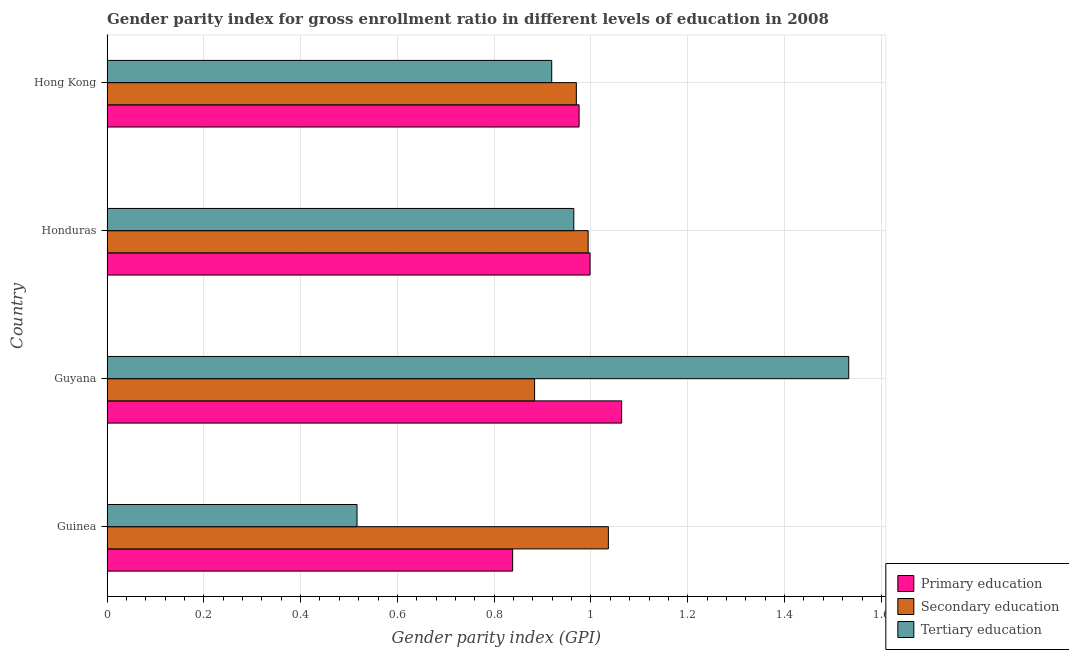How many different coloured bars are there?
Provide a succinct answer. 3. Are the number of bars on each tick of the Y-axis equal?
Provide a succinct answer. Yes. How many bars are there on the 4th tick from the top?
Provide a succinct answer. 3. What is the label of the 1st group of bars from the top?
Give a very brief answer. Hong Kong. In how many cases, is the number of bars for a given country not equal to the number of legend labels?
Give a very brief answer. 0. What is the gender parity index in secondary education in Honduras?
Offer a very short reply. 0.99. Across all countries, what is the maximum gender parity index in primary education?
Your answer should be very brief. 1.06. Across all countries, what is the minimum gender parity index in tertiary education?
Give a very brief answer. 0.52. In which country was the gender parity index in primary education maximum?
Offer a terse response. Guyana. In which country was the gender parity index in tertiary education minimum?
Ensure brevity in your answer.  Guinea. What is the total gender parity index in secondary education in the graph?
Your answer should be very brief. 3.88. What is the difference between the gender parity index in secondary education in Guinea and that in Hong Kong?
Your answer should be very brief. 0.07. What is the difference between the gender parity index in primary education in Guyana and the gender parity index in tertiary education in Guinea?
Your answer should be very brief. 0.55. What is the average gender parity index in secondary education per country?
Your response must be concise. 0.97. What is the difference between the gender parity index in secondary education and gender parity index in tertiary education in Hong Kong?
Provide a short and direct response. 0.05. In how many countries, is the gender parity index in tertiary education greater than 0.8400000000000001 ?
Offer a terse response. 3. What is the ratio of the gender parity index in secondary education in Guinea to that in Honduras?
Give a very brief answer. 1.04. What is the difference between the highest and the second highest gender parity index in secondary education?
Your answer should be very brief. 0.04. What is the difference between the highest and the lowest gender parity index in primary education?
Make the answer very short. 0.23. In how many countries, is the gender parity index in primary education greater than the average gender parity index in primary education taken over all countries?
Make the answer very short. 3. Is the sum of the gender parity index in tertiary education in Guinea and Hong Kong greater than the maximum gender parity index in secondary education across all countries?
Ensure brevity in your answer.  Yes. What does the 1st bar from the top in Guinea represents?
Ensure brevity in your answer.  Tertiary education. What does the 2nd bar from the bottom in Hong Kong represents?
Provide a succinct answer. Secondary education. Is it the case that in every country, the sum of the gender parity index in primary education and gender parity index in secondary education is greater than the gender parity index in tertiary education?
Your answer should be compact. Yes. Are all the bars in the graph horizontal?
Make the answer very short. Yes. What is the title of the graph?
Make the answer very short. Gender parity index for gross enrollment ratio in different levels of education in 2008. Does "Secondary" appear as one of the legend labels in the graph?
Give a very brief answer. No. What is the label or title of the X-axis?
Provide a succinct answer. Gender parity index (GPI). What is the Gender parity index (GPI) of Primary education in Guinea?
Your answer should be compact. 0.84. What is the Gender parity index (GPI) in Secondary education in Guinea?
Your answer should be compact. 1.04. What is the Gender parity index (GPI) of Tertiary education in Guinea?
Your response must be concise. 0.52. What is the Gender parity index (GPI) of Primary education in Guyana?
Provide a succinct answer. 1.06. What is the Gender parity index (GPI) in Secondary education in Guyana?
Keep it short and to the point. 0.88. What is the Gender parity index (GPI) of Tertiary education in Guyana?
Provide a succinct answer. 1.53. What is the Gender parity index (GPI) of Primary education in Honduras?
Your answer should be compact. 1. What is the Gender parity index (GPI) of Secondary education in Honduras?
Offer a very short reply. 0.99. What is the Gender parity index (GPI) in Tertiary education in Honduras?
Keep it short and to the point. 0.96. What is the Gender parity index (GPI) in Primary education in Hong Kong?
Your answer should be compact. 0.98. What is the Gender parity index (GPI) in Secondary education in Hong Kong?
Provide a succinct answer. 0.97. What is the Gender parity index (GPI) in Tertiary education in Hong Kong?
Make the answer very short. 0.92. Across all countries, what is the maximum Gender parity index (GPI) in Primary education?
Provide a short and direct response. 1.06. Across all countries, what is the maximum Gender parity index (GPI) of Secondary education?
Make the answer very short. 1.04. Across all countries, what is the maximum Gender parity index (GPI) of Tertiary education?
Your answer should be compact. 1.53. Across all countries, what is the minimum Gender parity index (GPI) in Primary education?
Your answer should be compact. 0.84. Across all countries, what is the minimum Gender parity index (GPI) of Secondary education?
Offer a very short reply. 0.88. Across all countries, what is the minimum Gender parity index (GPI) in Tertiary education?
Your answer should be very brief. 0.52. What is the total Gender parity index (GPI) in Primary education in the graph?
Your answer should be compact. 3.88. What is the total Gender parity index (GPI) of Secondary education in the graph?
Your answer should be compact. 3.88. What is the total Gender parity index (GPI) of Tertiary education in the graph?
Provide a short and direct response. 3.93. What is the difference between the Gender parity index (GPI) of Primary education in Guinea and that in Guyana?
Your response must be concise. -0.23. What is the difference between the Gender parity index (GPI) in Secondary education in Guinea and that in Guyana?
Give a very brief answer. 0.15. What is the difference between the Gender parity index (GPI) of Tertiary education in Guinea and that in Guyana?
Provide a short and direct response. -1.02. What is the difference between the Gender parity index (GPI) of Primary education in Guinea and that in Honduras?
Make the answer very short. -0.16. What is the difference between the Gender parity index (GPI) of Secondary education in Guinea and that in Honduras?
Your response must be concise. 0.04. What is the difference between the Gender parity index (GPI) in Tertiary education in Guinea and that in Honduras?
Your response must be concise. -0.45. What is the difference between the Gender parity index (GPI) of Primary education in Guinea and that in Hong Kong?
Ensure brevity in your answer.  -0.14. What is the difference between the Gender parity index (GPI) of Secondary education in Guinea and that in Hong Kong?
Offer a terse response. 0.07. What is the difference between the Gender parity index (GPI) in Tertiary education in Guinea and that in Hong Kong?
Provide a short and direct response. -0.4. What is the difference between the Gender parity index (GPI) in Primary education in Guyana and that in Honduras?
Offer a terse response. 0.07. What is the difference between the Gender parity index (GPI) in Secondary education in Guyana and that in Honduras?
Your response must be concise. -0.11. What is the difference between the Gender parity index (GPI) of Tertiary education in Guyana and that in Honduras?
Ensure brevity in your answer.  0.57. What is the difference between the Gender parity index (GPI) of Primary education in Guyana and that in Hong Kong?
Make the answer very short. 0.09. What is the difference between the Gender parity index (GPI) in Secondary education in Guyana and that in Hong Kong?
Offer a very short reply. -0.09. What is the difference between the Gender parity index (GPI) in Tertiary education in Guyana and that in Hong Kong?
Offer a very short reply. 0.61. What is the difference between the Gender parity index (GPI) in Primary education in Honduras and that in Hong Kong?
Your answer should be compact. 0.02. What is the difference between the Gender parity index (GPI) in Secondary education in Honduras and that in Hong Kong?
Provide a short and direct response. 0.02. What is the difference between the Gender parity index (GPI) in Tertiary education in Honduras and that in Hong Kong?
Give a very brief answer. 0.05. What is the difference between the Gender parity index (GPI) of Primary education in Guinea and the Gender parity index (GPI) of Secondary education in Guyana?
Make the answer very short. -0.05. What is the difference between the Gender parity index (GPI) in Primary education in Guinea and the Gender parity index (GPI) in Tertiary education in Guyana?
Provide a short and direct response. -0.69. What is the difference between the Gender parity index (GPI) of Secondary education in Guinea and the Gender parity index (GPI) of Tertiary education in Guyana?
Offer a terse response. -0.5. What is the difference between the Gender parity index (GPI) of Primary education in Guinea and the Gender parity index (GPI) of Secondary education in Honduras?
Your response must be concise. -0.16. What is the difference between the Gender parity index (GPI) in Primary education in Guinea and the Gender parity index (GPI) in Tertiary education in Honduras?
Your response must be concise. -0.13. What is the difference between the Gender parity index (GPI) of Secondary education in Guinea and the Gender parity index (GPI) of Tertiary education in Honduras?
Give a very brief answer. 0.07. What is the difference between the Gender parity index (GPI) of Primary education in Guinea and the Gender parity index (GPI) of Secondary education in Hong Kong?
Your response must be concise. -0.13. What is the difference between the Gender parity index (GPI) of Primary education in Guinea and the Gender parity index (GPI) of Tertiary education in Hong Kong?
Your answer should be very brief. -0.08. What is the difference between the Gender parity index (GPI) of Secondary education in Guinea and the Gender parity index (GPI) of Tertiary education in Hong Kong?
Your answer should be very brief. 0.12. What is the difference between the Gender parity index (GPI) of Primary education in Guyana and the Gender parity index (GPI) of Secondary education in Honduras?
Provide a succinct answer. 0.07. What is the difference between the Gender parity index (GPI) in Primary education in Guyana and the Gender parity index (GPI) in Tertiary education in Honduras?
Your answer should be compact. 0.1. What is the difference between the Gender parity index (GPI) in Secondary education in Guyana and the Gender parity index (GPI) in Tertiary education in Honduras?
Your response must be concise. -0.08. What is the difference between the Gender parity index (GPI) in Primary education in Guyana and the Gender parity index (GPI) in Secondary education in Hong Kong?
Offer a very short reply. 0.09. What is the difference between the Gender parity index (GPI) in Primary education in Guyana and the Gender parity index (GPI) in Tertiary education in Hong Kong?
Provide a succinct answer. 0.14. What is the difference between the Gender parity index (GPI) of Secondary education in Guyana and the Gender parity index (GPI) of Tertiary education in Hong Kong?
Provide a short and direct response. -0.04. What is the difference between the Gender parity index (GPI) of Primary education in Honduras and the Gender parity index (GPI) of Secondary education in Hong Kong?
Provide a succinct answer. 0.03. What is the difference between the Gender parity index (GPI) in Primary education in Honduras and the Gender parity index (GPI) in Tertiary education in Hong Kong?
Your answer should be very brief. 0.08. What is the difference between the Gender parity index (GPI) of Secondary education in Honduras and the Gender parity index (GPI) of Tertiary education in Hong Kong?
Ensure brevity in your answer.  0.08. What is the average Gender parity index (GPI) of Primary education per country?
Provide a succinct answer. 0.97. What is the average Gender parity index (GPI) of Secondary education per country?
Offer a very short reply. 0.97. What is the average Gender parity index (GPI) of Tertiary education per country?
Give a very brief answer. 0.98. What is the difference between the Gender parity index (GPI) in Primary education and Gender parity index (GPI) in Secondary education in Guinea?
Offer a very short reply. -0.2. What is the difference between the Gender parity index (GPI) of Primary education and Gender parity index (GPI) of Tertiary education in Guinea?
Make the answer very short. 0.32. What is the difference between the Gender parity index (GPI) of Secondary education and Gender parity index (GPI) of Tertiary education in Guinea?
Provide a short and direct response. 0.52. What is the difference between the Gender parity index (GPI) in Primary education and Gender parity index (GPI) in Secondary education in Guyana?
Your answer should be very brief. 0.18. What is the difference between the Gender parity index (GPI) of Primary education and Gender parity index (GPI) of Tertiary education in Guyana?
Provide a succinct answer. -0.47. What is the difference between the Gender parity index (GPI) in Secondary education and Gender parity index (GPI) in Tertiary education in Guyana?
Make the answer very short. -0.65. What is the difference between the Gender parity index (GPI) of Primary education and Gender parity index (GPI) of Secondary education in Honduras?
Ensure brevity in your answer.  0. What is the difference between the Gender parity index (GPI) in Primary education and Gender parity index (GPI) in Tertiary education in Honduras?
Provide a short and direct response. 0.03. What is the difference between the Gender parity index (GPI) in Secondary education and Gender parity index (GPI) in Tertiary education in Honduras?
Provide a short and direct response. 0.03. What is the difference between the Gender parity index (GPI) in Primary education and Gender parity index (GPI) in Secondary education in Hong Kong?
Provide a succinct answer. 0.01. What is the difference between the Gender parity index (GPI) in Primary education and Gender parity index (GPI) in Tertiary education in Hong Kong?
Ensure brevity in your answer.  0.06. What is the difference between the Gender parity index (GPI) of Secondary education and Gender parity index (GPI) of Tertiary education in Hong Kong?
Your answer should be compact. 0.05. What is the ratio of the Gender parity index (GPI) in Primary education in Guinea to that in Guyana?
Your answer should be compact. 0.79. What is the ratio of the Gender parity index (GPI) in Secondary education in Guinea to that in Guyana?
Provide a short and direct response. 1.17. What is the ratio of the Gender parity index (GPI) in Tertiary education in Guinea to that in Guyana?
Your response must be concise. 0.34. What is the ratio of the Gender parity index (GPI) of Primary education in Guinea to that in Honduras?
Your response must be concise. 0.84. What is the ratio of the Gender parity index (GPI) of Secondary education in Guinea to that in Honduras?
Your response must be concise. 1.04. What is the ratio of the Gender parity index (GPI) of Tertiary education in Guinea to that in Honduras?
Your answer should be very brief. 0.54. What is the ratio of the Gender parity index (GPI) of Primary education in Guinea to that in Hong Kong?
Offer a very short reply. 0.86. What is the ratio of the Gender parity index (GPI) of Secondary education in Guinea to that in Hong Kong?
Provide a succinct answer. 1.07. What is the ratio of the Gender parity index (GPI) in Tertiary education in Guinea to that in Hong Kong?
Make the answer very short. 0.56. What is the ratio of the Gender parity index (GPI) in Primary education in Guyana to that in Honduras?
Offer a terse response. 1.07. What is the ratio of the Gender parity index (GPI) in Secondary education in Guyana to that in Honduras?
Provide a short and direct response. 0.89. What is the ratio of the Gender parity index (GPI) in Tertiary education in Guyana to that in Honduras?
Give a very brief answer. 1.59. What is the ratio of the Gender parity index (GPI) in Primary education in Guyana to that in Hong Kong?
Your answer should be compact. 1.09. What is the ratio of the Gender parity index (GPI) in Secondary education in Guyana to that in Hong Kong?
Offer a very short reply. 0.91. What is the ratio of the Gender parity index (GPI) in Tertiary education in Guyana to that in Hong Kong?
Your answer should be compact. 1.67. What is the ratio of the Gender parity index (GPI) of Primary education in Honduras to that in Hong Kong?
Offer a very short reply. 1.02. What is the ratio of the Gender parity index (GPI) of Secondary education in Honduras to that in Hong Kong?
Your answer should be very brief. 1.03. What is the ratio of the Gender parity index (GPI) of Tertiary education in Honduras to that in Hong Kong?
Offer a very short reply. 1.05. What is the difference between the highest and the second highest Gender parity index (GPI) of Primary education?
Provide a short and direct response. 0.07. What is the difference between the highest and the second highest Gender parity index (GPI) of Secondary education?
Ensure brevity in your answer.  0.04. What is the difference between the highest and the second highest Gender parity index (GPI) of Tertiary education?
Make the answer very short. 0.57. What is the difference between the highest and the lowest Gender parity index (GPI) in Primary education?
Provide a succinct answer. 0.23. What is the difference between the highest and the lowest Gender parity index (GPI) of Secondary education?
Your answer should be very brief. 0.15. 